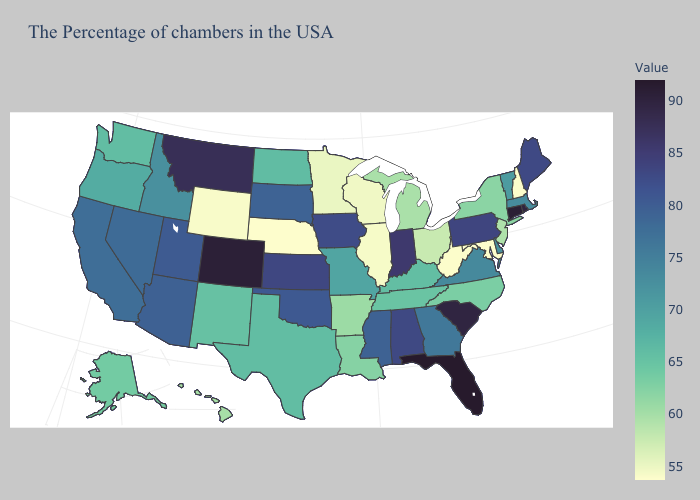Does Florida have the highest value in the USA?
Write a very short answer. Yes. Does the map have missing data?
Keep it brief. No. Does Connecticut have the highest value in the Northeast?
Concise answer only. Yes. 